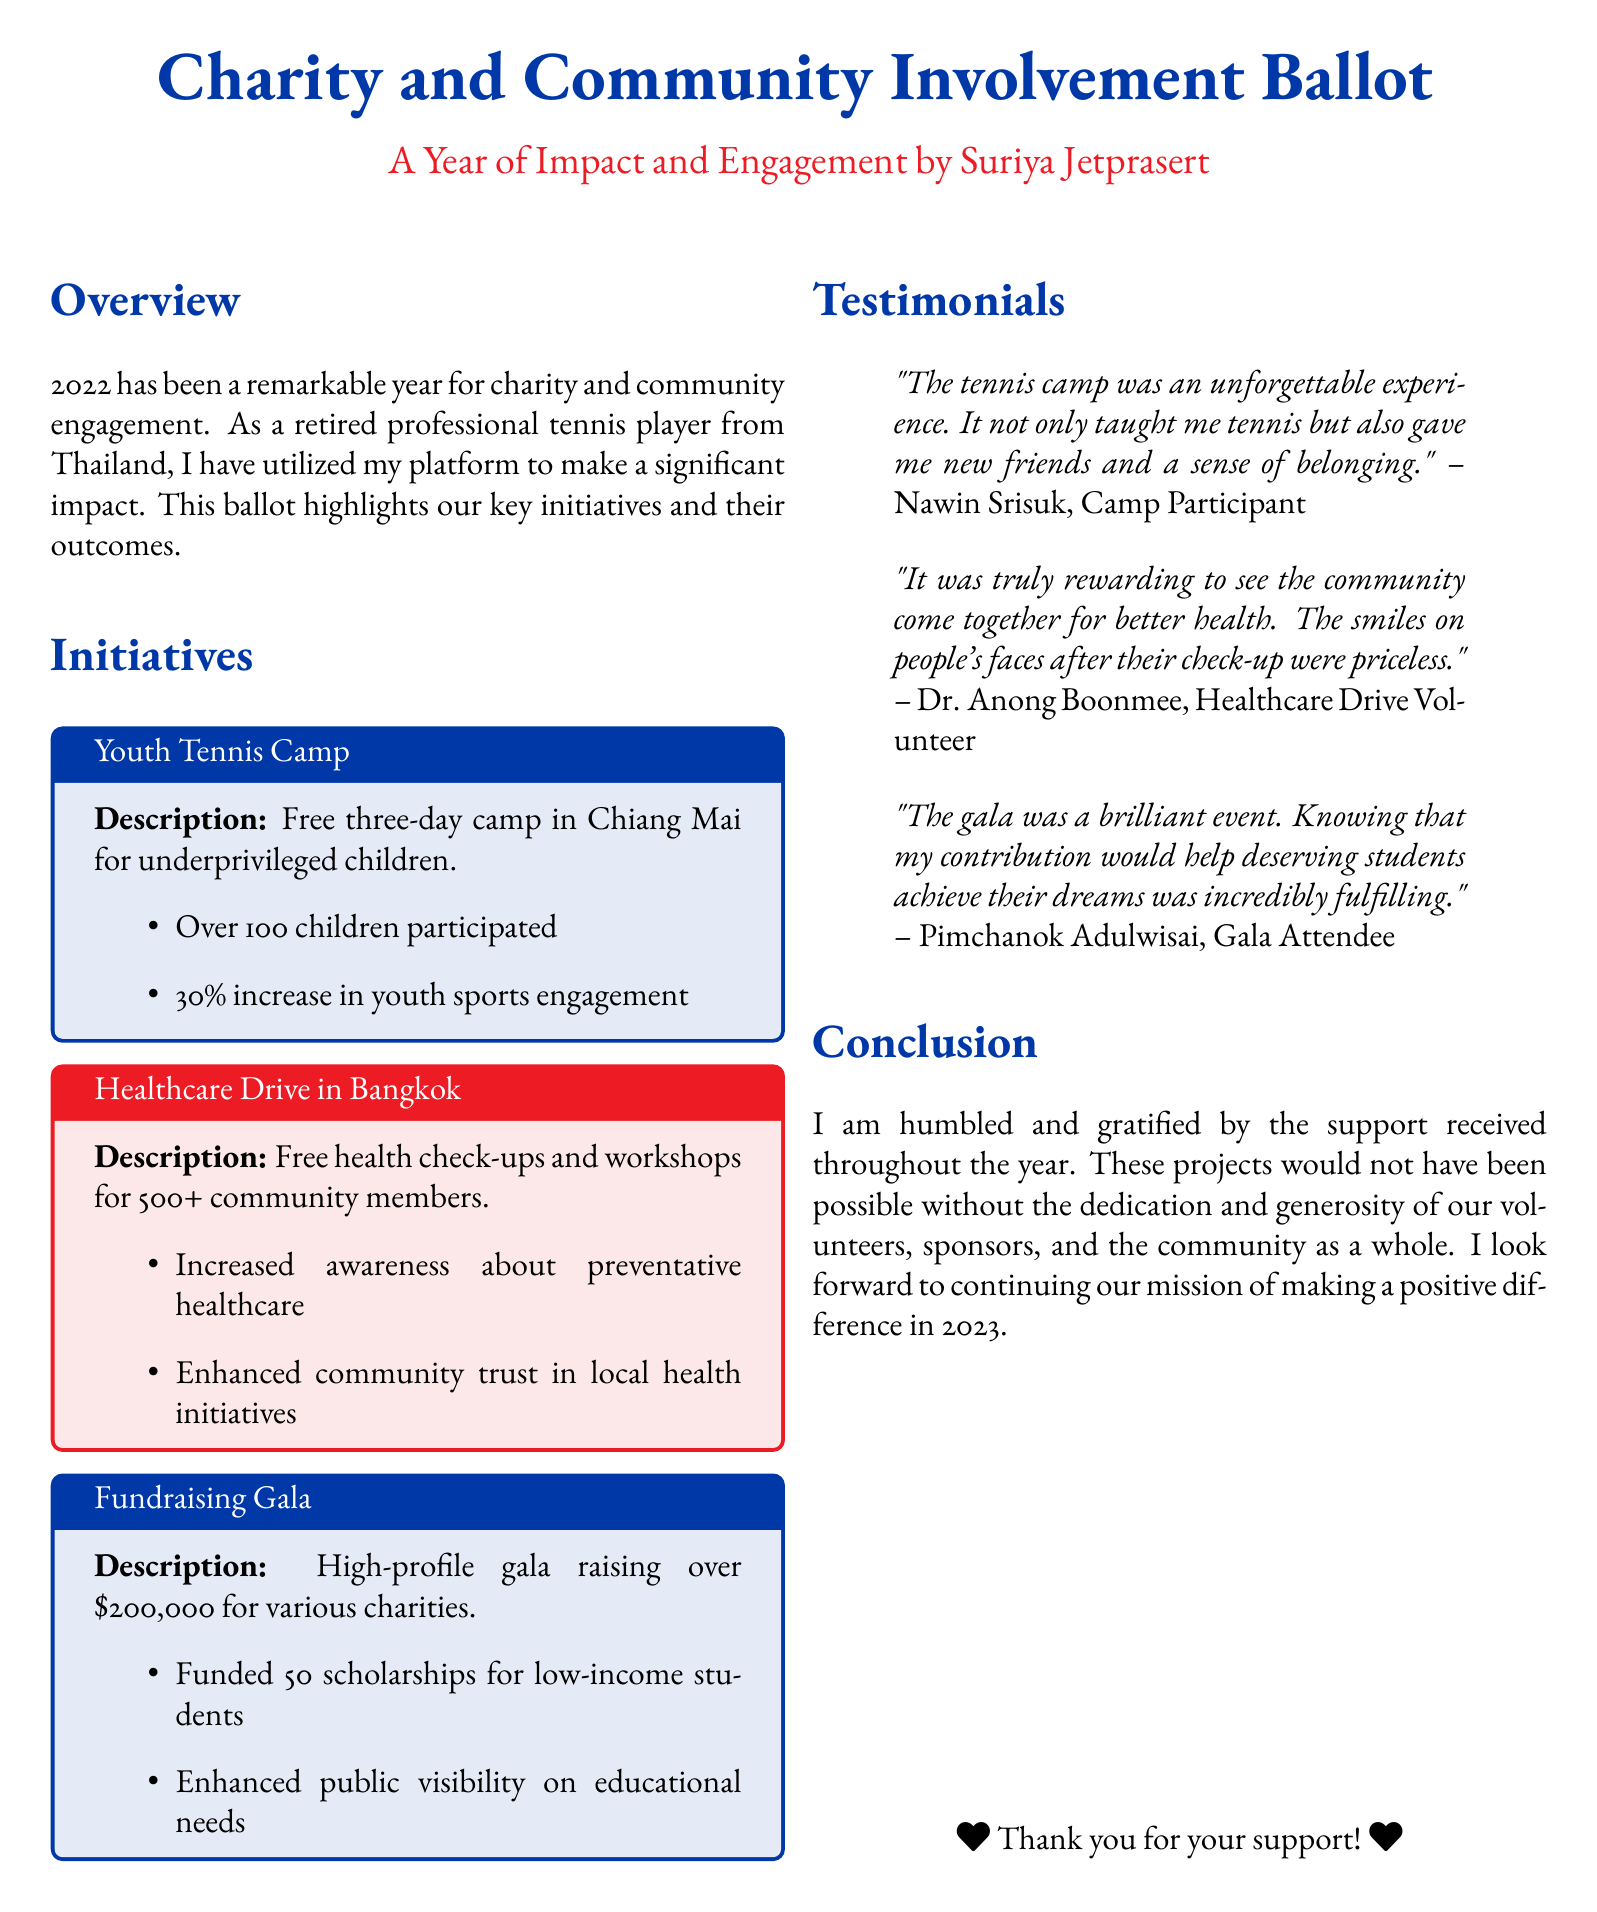what was the location of the youth tennis camp? The youth tennis camp took place in Chiang Mai, which is mentioned as the description of the initiative.
Answer: Chiang Mai how many children participated in the youth tennis camp? The document states that over 100 children participated in the camp, providing a specific figure.
Answer: Over 100 what was the total amount raised at the fundraising gala? The gala raised over $200,000 for various charities, as noted in the initiative section.
Answer: Over $200,000 how many scholarships were funded by the gala? The document specifies that the fundraising gala funded 50 scholarships for low-income students.
Answer: 50 scholarships who is the camp participant quoted in the testimonials? The quotation for the camp experience was attributed to Nawin Srisuk, identified in the testimonials section.
Answer: Nawin Srisuk what percentage increase in youth sports engagement was reported? The initiatives include a 30% increase in youth sports engagement, highlighting the impact of the camp.
Answer: 30% what type of healthcare services were provided in Bangkok? The document describes free health check-ups and workshops offered during the healthcare drive.
Answer: Health check-ups and workshops who expressed fulfillment from attending the gala? The testimony section includes a quote from Pimchanok Adulwisai, who attended the gala.
Answer: Pimchanok Adulwisai how many community members were involved in the healthcare drive? The document indicates that over 500 community members received services during the healthcare drive.
Answer: Over 500 